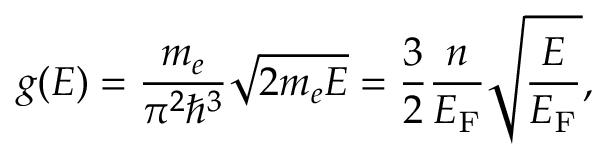Convert formula to latex. <formula><loc_0><loc_0><loc_500><loc_500>g ( E ) = { \frac { m _ { e } } { \pi ^ { 2 } \hbar { ^ } { 3 } } } { \sqrt { 2 m _ { e } E } } = { \frac { 3 } { 2 } } { \frac { n } { E _ { F } } } { \sqrt { \frac { E } { E _ { F } } } } ,</formula> 